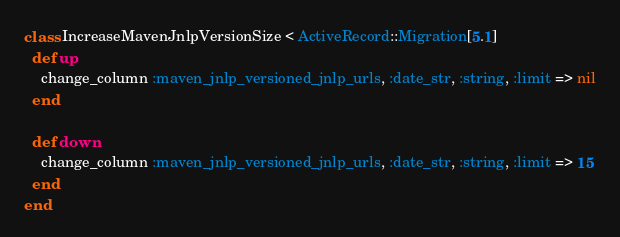<code> <loc_0><loc_0><loc_500><loc_500><_Ruby_>class IncreaseMavenJnlpVersionSize < ActiveRecord::Migration[5.1]
  def up
    change_column :maven_jnlp_versioned_jnlp_urls, :date_str, :string, :limit => nil
  end

  def down
    change_column :maven_jnlp_versioned_jnlp_urls, :date_str, :string, :limit => 15
  end
end
</code> 